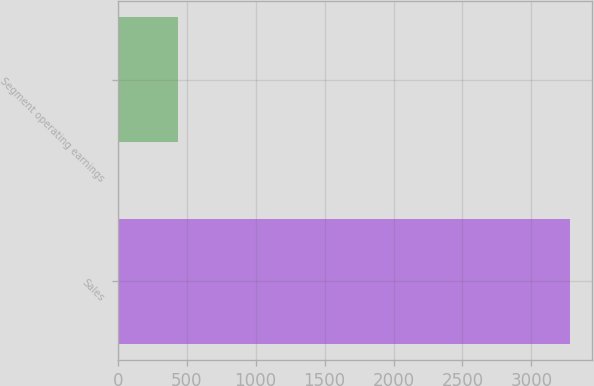<chart> <loc_0><loc_0><loc_500><loc_500><bar_chart><fcel>Sales<fcel>Segment operating earnings<nl><fcel>3278.1<fcel>440.5<nl></chart> 